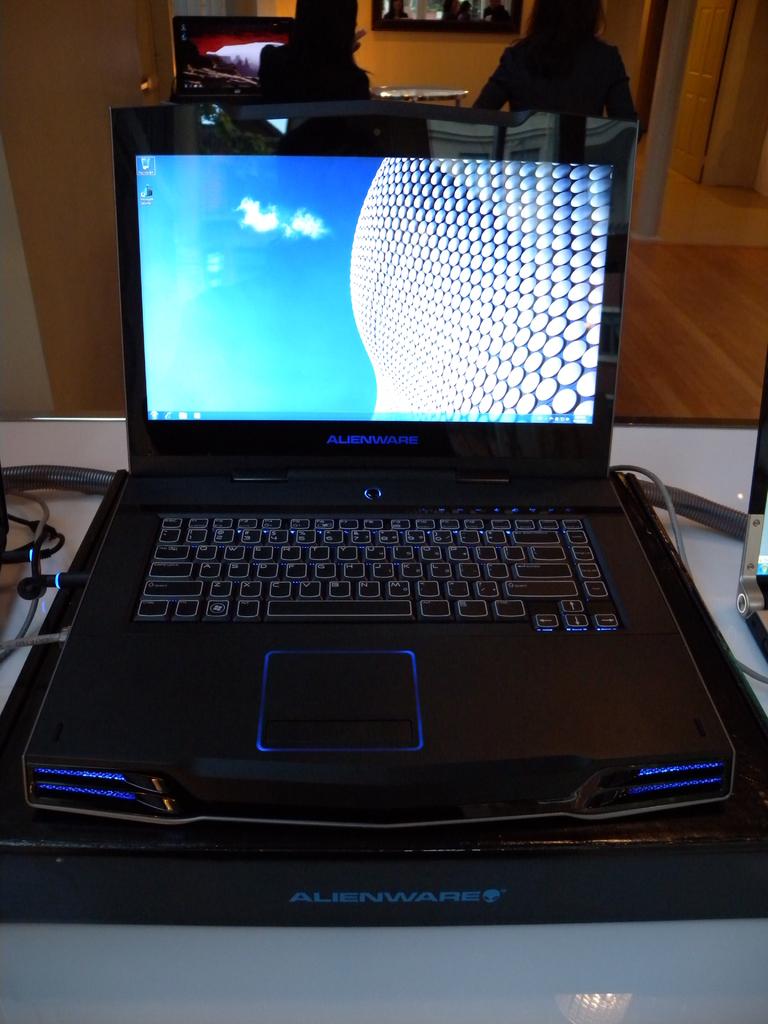What brand of laptop?
Make the answer very short. Alienware. 